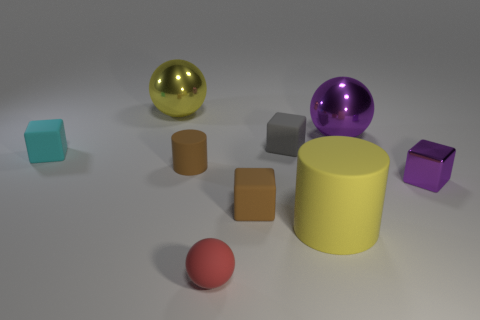Subtract all small matte spheres. How many spheres are left? 2 Subtract all purple cubes. How many cubes are left? 3 Add 1 purple cubes. How many objects exist? 10 Add 3 big metallic objects. How many big metallic objects are left? 5 Add 9 small cyan metallic spheres. How many small cyan metallic spheres exist? 9 Subtract 0 cyan balls. How many objects are left? 9 Subtract all spheres. How many objects are left? 6 Subtract 2 spheres. How many spheres are left? 1 Subtract all cyan cylinders. Subtract all brown balls. How many cylinders are left? 2 Subtract all cyan cylinders. How many red balls are left? 1 